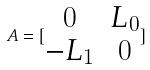Convert formula to latex. <formula><loc_0><loc_0><loc_500><loc_500>A = [ \begin{matrix} 0 & L _ { 0 } \\ - L _ { 1 } & 0 \end{matrix} ]</formula> 